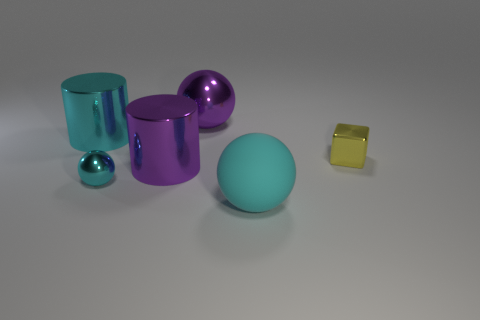Can you describe the shapes present and their possible symbolic meanings? The image contains a mix of geometric shapes, including spheres, cylinders, and a cube. Spheres often symbolize completeness and unity, representing an unbroken and infinite loop. Cylinders could symbolize stability and strength, with their solid bases and round edges. The cube might be seen as a symbol of stability and building blocks, hinting at structure and foundation. Together, these shapes could represent a harmoniously structured universe or the diversity and unity within it. 